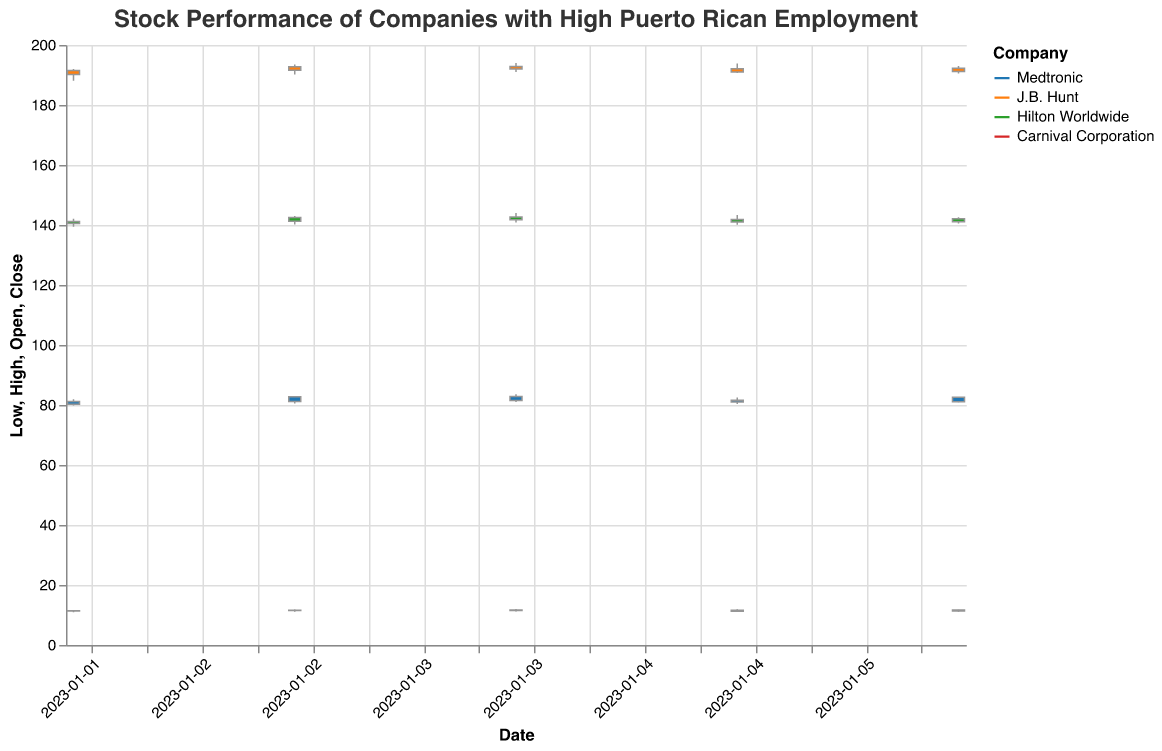What is the title of the chart? The title of the chart is displayed at the top of the figure, which is "Stock Performance of Companies with High Puerto Rican Employment".
Answer: Stock Performance of Companies with High Puerto Rican Employment What is the date range covered by the data in the plot? The date range covered by the data in the plot can be determined by looking at the horizontal axis, which shows dates from "2023-01-02" to "2023-01-06".
Answer: January 2, 2023 to January 6, 2023 Which company had the highest closing price on January 4, 2023? To find the highest closing price on January 4, 2023, we observe the closing prices of all companies on this date and compare them. J.B. Hunt had the highest closing price of $192.00.
Answer: J.B. Hunt What was the difference between the highest and lowest stock prices for Hilton Worldwide on January 3, 2023? To find the difference, subtract the lowest stock price from the highest stock price for Hilton Worldwide on January 3, 2023. The highest price was $143.00 and the lowest was $140.20. The difference is $143.00 - $140.20 = $2.80.
Answer: $2.80 Which company's stock price showed an overall increase over the 5-day period? By comparing the closing prices from January 2, 2023, to January 6, 2023, we can determine the overall change in stock prices for each company. Medtronic closed higher (from $81.15 to $82.55), J.B. Hunt also closed higher (from $191.50 to $192.25), Hilton Worldwide closed almost the same with a minimal increase, and Carnival Corporation closed higher (from $11.45 to $11.65). All three companies, except Hilton Worldwide, showed an overall increase, but Hilton had a minuscule increase.
Answer: Medtronic, J.B. Hunt, Carnival Corporation What was the average closing price for Medtronic over the 5-day period? To find the average closing price, sum Medtronic's closing prices from the chart and divide by the number of days: (81.15 + 82.75 + 81.50 + 81.00 + 82.55) / 5 = 409.95 / 5 = 81.99.
Answer: $81.99 Which company had the smallest variation in stock price on January 5, 2023? To find the smallest variation, we need to calculate the difference between the high and low prices for each company on January 5, 2023. Medtronic: $82.50 - $80.30 = $2.20, J.B. Hunt: $193.80 - $190.70 = $3.10, Hilton Worldwide: $143.30 - $140.10 = $3.20, Carnival Corporation: $11.90 - $11.00 = $0.90. Carnival Corporation had the smallest variation of $0.90.
Answer: Carnival Corporation On which date did Medtronic have the highest trading volume? The trading volume can be found in the "Volume" field. By comparing the volumes for Medtronic, we see that January 4, 2023, had the highest trading volume of 1,305,000.
Answer: January 4, 2023 Which two companies had the most similar closing prices on January 2, 2023? By comparing the closing prices of all companies on January 2, 2023, Medtronic ($81.15) and Hilton Worldwide ($141.20) have the most similar prices, but since the question asks for the similarity, we need the closest ones. Therefore, Medtronic ($81.15) and Hilton Worldwide ($141.20) show the closest valuation metric though not exactly close numerically against each other. We see J.B. Hunt ($191.50) is in entirely different price tier, as is Carnival Corporation ($11.45).
Answer: Medtronic and Hilton Worldwide 